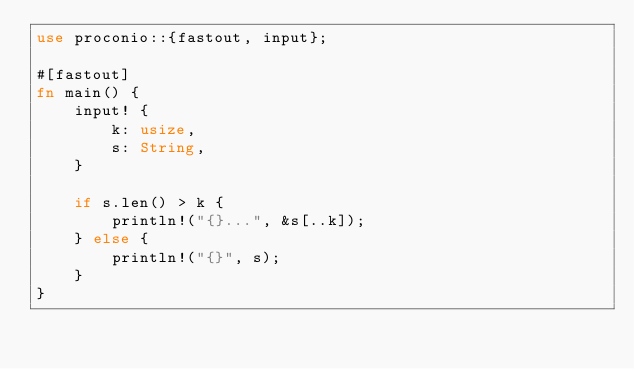Convert code to text. <code><loc_0><loc_0><loc_500><loc_500><_Rust_>use proconio::{fastout, input};

#[fastout]
fn main() {
    input! {
        k: usize,
        s: String,
    }

    if s.len() > k {
        println!("{}...", &s[..k]);
    } else {
        println!("{}", s);
    }
}
</code> 